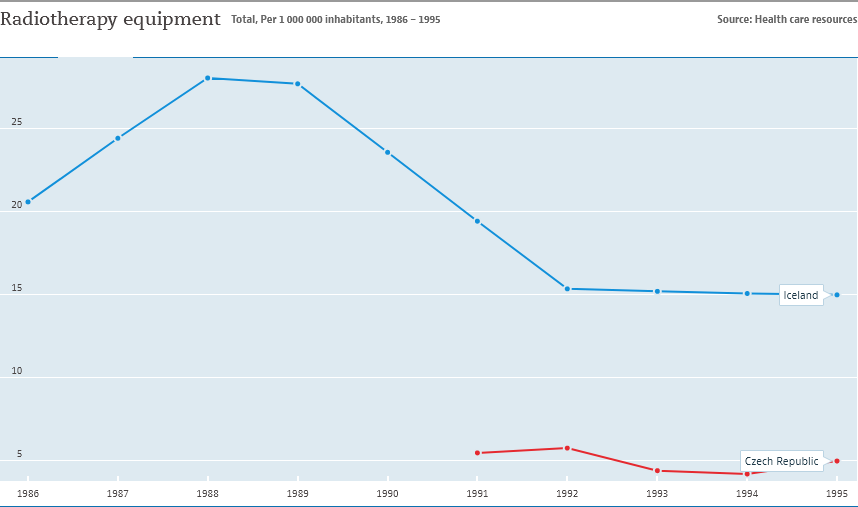Could the data presented be used to infer anything about the healthcare systems of the two countries? While the data specificity is limited to radiotherapy equipment, it suggests that Iceland had more equipment per capita than the Czech Republic during this period. However, to draw comprehensive conclusions about the healthcare systems' quality or efficiency, more information on other medical resources, staff, and patient outcomes would be needed. 